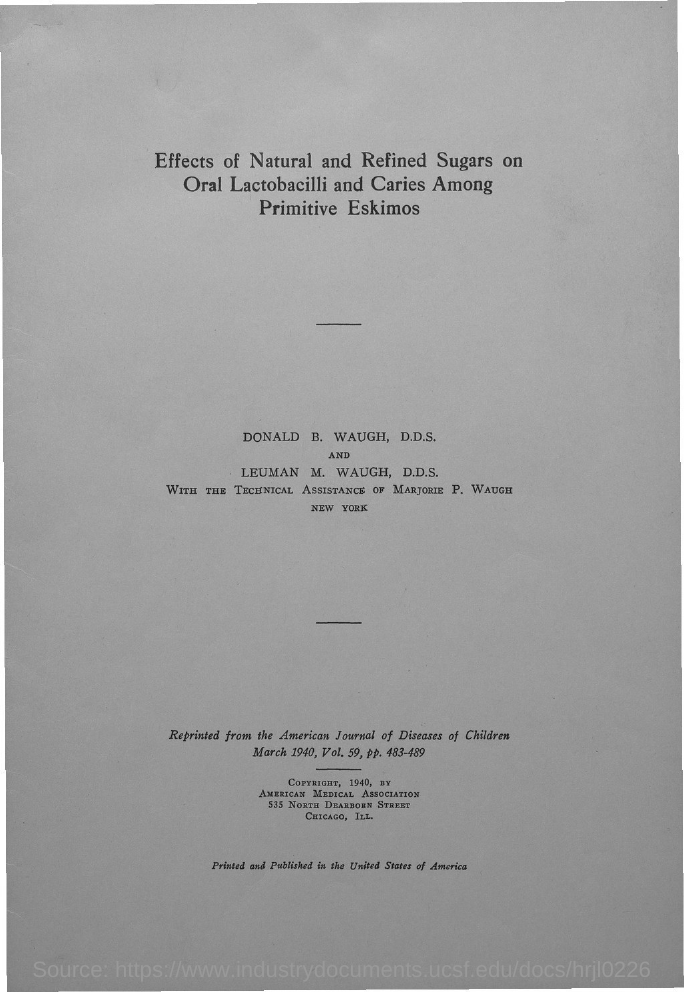List a handful of essential elements in this visual. The study aimed to examine the effects of natural and refined sugars on oral lactobacilli and the incidence of dental caries among primitive Eskimos. The American Medical Association owns the copyright. The paper titled "From which Journal is it reprinted from? American Journal of Diseases of Children." is a reprint from the American Journal of Diseases of Children. The volume number of the journal is 59.. Marjorie P. Waugh provided the technical assistance. 